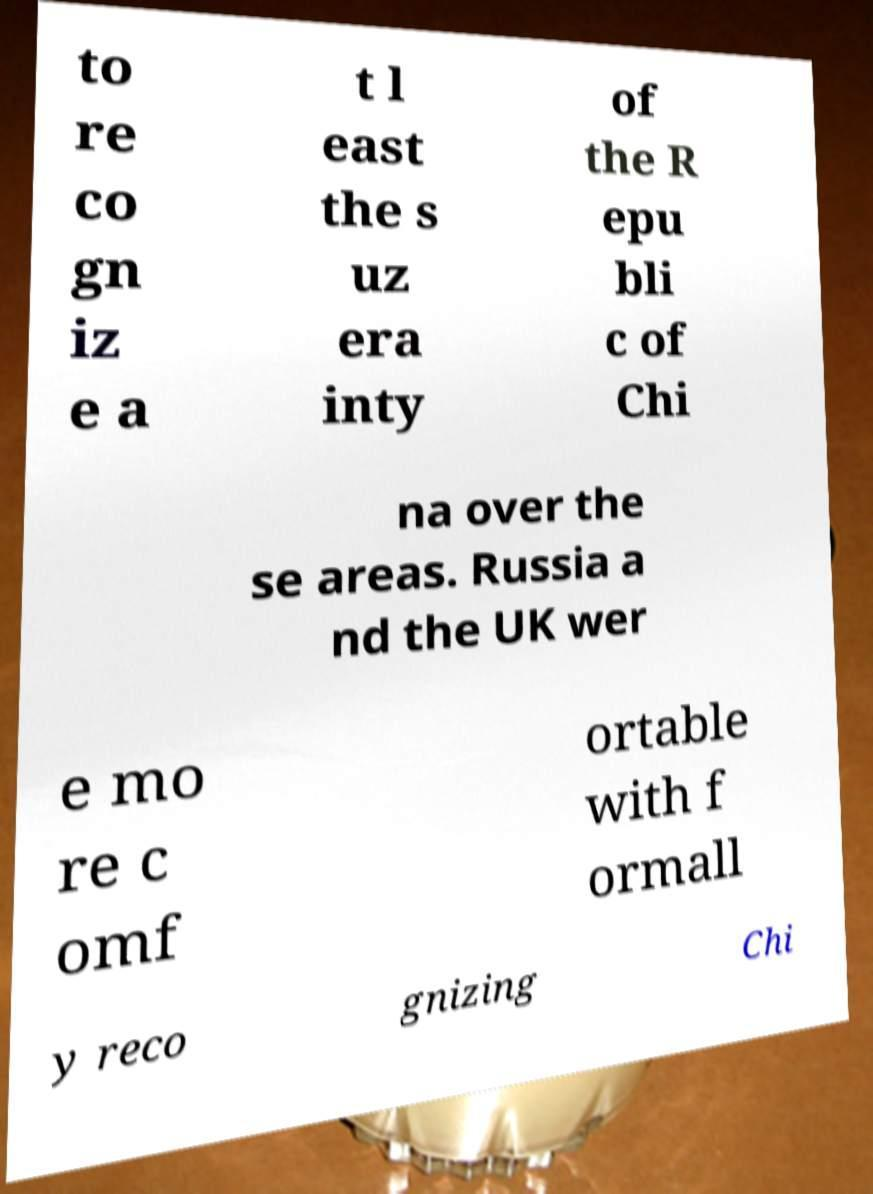Could you assist in decoding the text presented in this image and type it out clearly? to re co gn iz e a t l east the s uz era inty of the R epu bli c of Chi na over the se areas. Russia a nd the UK wer e mo re c omf ortable with f ormall y reco gnizing Chi 